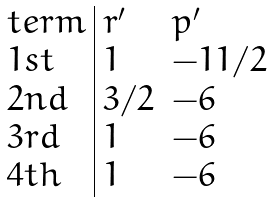<formula> <loc_0><loc_0><loc_500><loc_500>\begin{array} { l | l l } t e r m & r ^ { \prime } & p ^ { \prime } \\ 1 s t & 1 & - 1 1 / 2 \\ 2 n d & 3 / 2 & - 6 \\ 3 r d & 1 & - 6 \\ 4 t h & 1 & - 6 \end{array}</formula> 